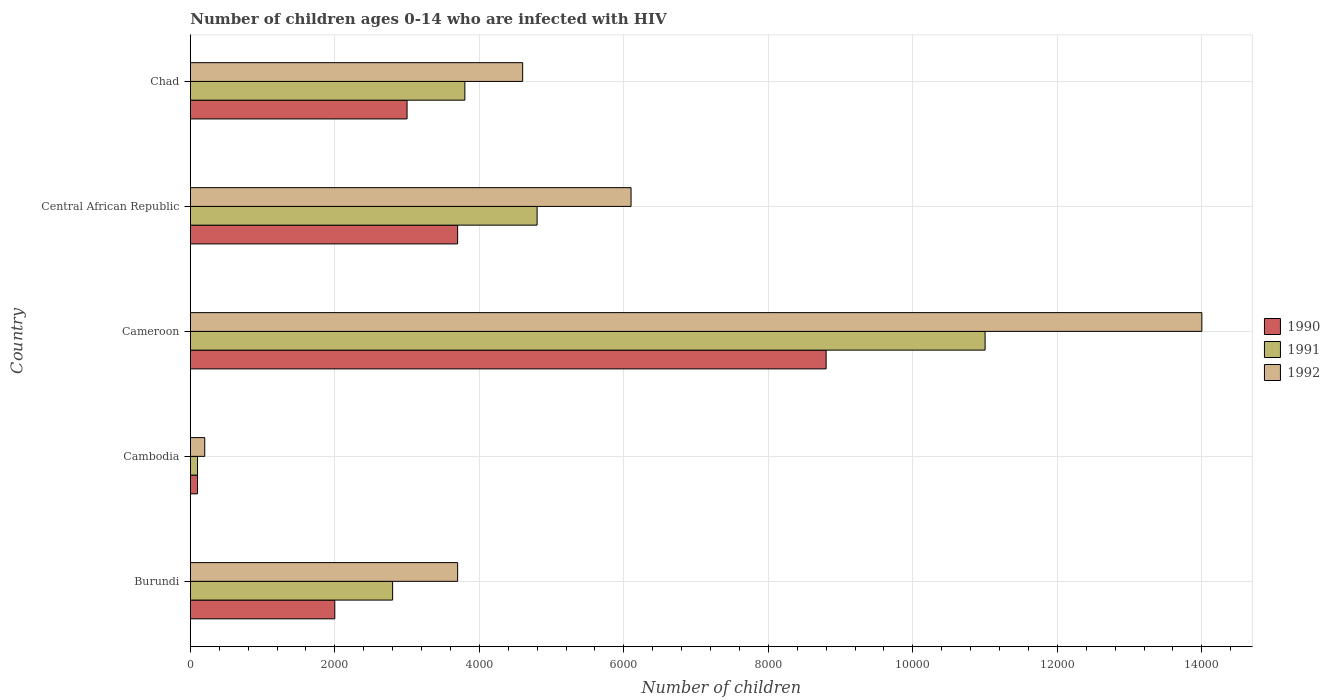How many groups of bars are there?
Ensure brevity in your answer.  5. Are the number of bars per tick equal to the number of legend labels?
Your answer should be compact. Yes. How many bars are there on the 1st tick from the top?
Ensure brevity in your answer.  3. How many bars are there on the 1st tick from the bottom?
Your answer should be very brief. 3. What is the label of the 4th group of bars from the top?
Ensure brevity in your answer.  Cambodia. What is the number of HIV infected children in 1991 in Chad?
Provide a short and direct response. 3800. Across all countries, what is the maximum number of HIV infected children in 1991?
Your answer should be very brief. 1.10e+04. Across all countries, what is the minimum number of HIV infected children in 1991?
Your answer should be compact. 100. In which country was the number of HIV infected children in 1991 maximum?
Offer a terse response. Cameroon. In which country was the number of HIV infected children in 1991 minimum?
Your response must be concise. Cambodia. What is the total number of HIV infected children in 1992 in the graph?
Provide a short and direct response. 2.86e+04. What is the difference between the number of HIV infected children in 1992 in Burundi and that in Chad?
Ensure brevity in your answer.  -900. What is the difference between the number of HIV infected children in 1991 in Cameroon and the number of HIV infected children in 1992 in Cambodia?
Ensure brevity in your answer.  1.08e+04. What is the average number of HIV infected children in 1992 per country?
Give a very brief answer. 5720. What is the difference between the number of HIV infected children in 1990 and number of HIV infected children in 1991 in Central African Republic?
Offer a terse response. -1100. What is the ratio of the number of HIV infected children in 1992 in Cameroon to that in Chad?
Make the answer very short. 3.04. Is the number of HIV infected children in 1990 in Cameroon less than that in Central African Republic?
Offer a terse response. No. Is the difference between the number of HIV infected children in 1990 in Burundi and Cambodia greater than the difference between the number of HIV infected children in 1991 in Burundi and Cambodia?
Your answer should be very brief. No. What is the difference between the highest and the second highest number of HIV infected children in 1990?
Provide a succinct answer. 5100. What is the difference between the highest and the lowest number of HIV infected children in 1992?
Make the answer very short. 1.38e+04. What does the 1st bar from the top in Chad represents?
Your answer should be compact. 1992. What does the 2nd bar from the bottom in Cameroon represents?
Your answer should be very brief. 1991. Is it the case that in every country, the sum of the number of HIV infected children in 1992 and number of HIV infected children in 1991 is greater than the number of HIV infected children in 1990?
Offer a very short reply. Yes. How many bars are there?
Keep it short and to the point. 15. Are all the bars in the graph horizontal?
Your response must be concise. Yes. Are the values on the major ticks of X-axis written in scientific E-notation?
Offer a terse response. No. Does the graph contain grids?
Offer a terse response. Yes. How many legend labels are there?
Your answer should be compact. 3. How are the legend labels stacked?
Your response must be concise. Vertical. What is the title of the graph?
Provide a short and direct response. Number of children ages 0-14 who are infected with HIV. What is the label or title of the X-axis?
Your answer should be compact. Number of children. What is the Number of children in 1990 in Burundi?
Ensure brevity in your answer.  2000. What is the Number of children of 1991 in Burundi?
Provide a short and direct response. 2800. What is the Number of children in 1992 in Burundi?
Your response must be concise. 3700. What is the Number of children in 1991 in Cambodia?
Your answer should be compact. 100. What is the Number of children of 1992 in Cambodia?
Your answer should be compact. 200. What is the Number of children in 1990 in Cameroon?
Make the answer very short. 8800. What is the Number of children of 1991 in Cameroon?
Keep it short and to the point. 1.10e+04. What is the Number of children of 1992 in Cameroon?
Give a very brief answer. 1.40e+04. What is the Number of children in 1990 in Central African Republic?
Provide a short and direct response. 3700. What is the Number of children of 1991 in Central African Republic?
Ensure brevity in your answer.  4800. What is the Number of children in 1992 in Central African Republic?
Offer a very short reply. 6100. What is the Number of children in 1990 in Chad?
Make the answer very short. 3000. What is the Number of children in 1991 in Chad?
Provide a succinct answer. 3800. What is the Number of children of 1992 in Chad?
Your answer should be compact. 4600. Across all countries, what is the maximum Number of children in 1990?
Provide a short and direct response. 8800. Across all countries, what is the maximum Number of children in 1991?
Ensure brevity in your answer.  1.10e+04. Across all countries, what is the maximum Number of children in 1992?
Offer a very short reply. 1.40e+04. Across all countries, what is the minimum Number of children of 1991?
Make the answer very short. 100. What is the total Number of children in 1990 in the graph?
Your response must be concise. 1.76e+04. What is the total Number of children of 1991 in the graph?
Offer a terse response. 2.25e+04. What is the total Number of children in 1992 in the graph?
Provide a succinct answer. 2.86e+04. What is the difference between the Number of children of 1990 in Burundi and that in Cambodia?
Your answer should be compact. 1900. What is the difference between the Number of children of 1991 in Burundi and that in Cambodia?
Your answer should be compact. 2700. What is the difference between the Number of children in 1992 in Burundi and that in Cambodia?
Offer a terse response. 3500. What is the difference between the Number of children in 1990 in Burundi and that in Cameroon?
Your response must be concise. -6800. What is the difference between the Number of children in 1991 in Burundi and that in Cameroon?
Your answer should be very brief. -8200. What is the difference between the Number of children in 1992 in Burundi and that in Cameroon?
Your response must be concise. -1.03e+04. What is the difference between the Number of children of 1990 in Burundi and that in Central African Republic?
Give a very brief answer. -1700. What is the difference between the Number of children in 1991 in Burundi and that in Central African Republic?
Your answer should be very brief. -2000. What is the difference between the Number of children of 1992 in Burundi and that in Central African Republic?
Make the answer very short. -2400. What is the difference between the Number of children of 1990 in Burundi and that in Chad?
Provide a short and direct response. -1000. What is the difference between the Number of children of 1991 in Burundi and that in Chad?
Offer a terse response. -1000. What is the difference between the Number of children of 1992 in Burundi and that in Chad?
Your response must be concise. -900. What is the difference between the Number of children of 1990 in Cambodia and that in Cameroon?
Ensure brevity in your answer.  -8700. What is the difference between the Number of children in 1991 in Cambodia and that in Cameroon?
Your answer should be very brief. -1.09e+04. What is the difference between the Number of children of 1992 in Cambodia and that in Cameroon?
Make the answer very short. -1.38e+04. What is the difference between the Number of children in 1990 in Cambodia and that in Central African Republic?
Give a very brief answer. -3600. What is the difference between the Number of children of 1991 in Cambodia and that in Central African Republic?
Make the answer very short. -4700. What is the difference between the Number of children of 1992 in Cambodia and that in Central African Republic?
Ensure brevity in your answer.  -5900. What is the difference between the Number of children of 1990 in Cambodia and that in Chad?
Your answer should be very brief. -2900. What is the difference between the Number of children in 1991 in Cambodia and that in Chad?
Give a very brief answer. -3700. What is the difference between the Number of children in 1992 in Cambodia and that in Chad?
Your response must be concise. -4400. What is the difference between the Number of children of 1990 in Cameroon and that in Central African Republic?
Your response must be concise. 5100. What is the difference between the Number of children of 1991 in Cameroon and that in Central African Republic?
Give a very brief answer. 6200. What is the difference between the Number of children of 1992 in Cameroon and that in Central African Republic?
Your answer should be compact. 7900. What is the difference between the Number of children of 1990 in Cameroon and that in Chad?
Keep it short and to the point. 5800. What is the difference between the Number of children of 1991 in Cameroon and that in Chad?
Your answer should be compact. 7200. What is the difference between the Number of children in 1992 in Cameroon and that in Chad?
Provide a short and direct response. 9400. What is the difference between the Number of children of 1990 in Central African Republic and that in Chad?
Provide a short and direct response. 700. What is the difference between the Number of children of 1991 in Central African Republic and that in Chad?
Provide a succinct answer. 1000. What is the difference between the Number of children in 1992 in Central African Republic and that in Chad?
Make the answer very short. 1500. What is the difference between the Number of children of 1990 in Burundi and the Number of children of 1991 in Cambodia?
Provide a short and direct response. 1900. What is the difference between the Number of children in 1990 in Burundi and the Number of children in 1992 in Cambodia?
Provide a succinct answer. 1800. What is the difference between the Number of children of 1991 in Burundi and the Number of children of 1992 in Cambodia?
Your answer should be very brief. 2600. What is the difference between the Number of children of 1990 in Burundi and the Number of children of 1991 in Cameroon?
Provide a short and direct response. -9000. What is the difference between the Number of children of 1990 in Burundi and the Number of children of 1992 in Cameroon?
Keep it short and to the point. -1.20e+04. What is the difference between the Number of children of 1991 in Burundi and the Number of children of 1992 in Cameroon?
Offer a terse response. -1.12e+04. What is the difference between the Number of children of 1990 in Burundi and the Number of children of 1991 in Central African Republic?
Provide a short and direct response. -2800. What is the difference between the Number of children of 1990 in Burundi and the Number of children of 1992 in Central African Republic?
Offer a terse response. -4100. What is the difference between the Number of children in 1991 in Burundi and the Number of children in 1992 in Central African Republic?
Provide a succinct answer. -3300. What is the difference between the Number of children of 1990 in Burundi and the Number of children of 1991 in Chad?
Make the answer very short. -1800. What is the difference between the Number of children in 1990 in Burundi and the Number of children in 1992 in Chad?
Make the answer very short. -2600. What is the difference between the Number of children in 1991 in Burundi and the Number of children in 1992 in Chad?
Provide a short and direct response. -1800. What is the difference between the Number of children of 1990 in Cambodia and the Number of children of 1991 in Cameroon?
Your answer should be compact. -1.09e+04. What is the difference between the Number of children of 1990 in Cambodia and the Number of children of 1992 in Cameroon?
Make the answer very short. -1.39e+04. What is the difference between the Number of children of 1991 in Cambodia and the Number of children of 1992 in Cameroon?
Your response must be concise. -1.39e+04. What is the difference between the Number of children in 1990 in Cambodia and the Number of children in 1991 in Central African Republic?
Keep it short and to the point. -4700. What is the difference between the Number of children of 1990 in Cambodia and the Number of children of 1992 in Central African Republic?
Your answer should be very brief. -6000. What is the difference between the Number of children in 1991 in Cambodia and the Number of children in 1992 in Central African Republic?
Keep it short and to the point. -6000. What is the difference between the Number of children of 1990 in Cambodia and the Number of children of 1991 in Chad?
Your answer should be compact. -3700. What is the difference between the Number of children in 1990 in Cambodia and the Number of children in 1992 in Chad?
Offer a very short reply. -4500. What is the difference between the Number of children of 1991 in Cambodia and the Number of children of 1992 in Chad?
Provide a short and direct response. -4500. What is the difference between the Number of children of 1990 in Cameroon and the Number of children of 1991 in Central African Republic?
Your answer should be compact. 4000. What is the difference between the Number of children in 1990 in Cameroon and the Number of children in 1992 in Central African Republic?
Your answer should be compact. 2700. What is the difference between the Number of children of 1991 in Cameroon and the Number of children of 1992 in Central African Republic?
Offer a terse response. 4900. What is the difference between the Number of children in 1990 in Cameroon and the Number of children in 1992 in Chad?
Ensure brevity in your answer.  4200. What is the difference between the Number of children in 1991 in Cameroon and the Number of children in 1992 in Chad?
Offer a very short reply. 6400. What is the difference between the Number of children of 1990 in Central African Republic and the Number of children of 1991 in Chad?
Provide a short and direct response. -100. What is the difference between the Number of children in 1990 in Central African Republic and the Number of children in 1992 in Chad?
Offer a terse response. -900. What is the difference between the Number of children in 1991 in Central African Republic and the Number of children in 1992 in Chad?
Keep it short and to the point. 200. What is the average Number of children in 1990 per country?
Your response must be concise. 3520. What is the average Number of children in 1991 per country?
Your answer should be very brief. 4500. What is the average Number of children of 1992 per country?
Make the answer very short. 5720. What is the difference between the Number of children in 1990 and Number of children in 1991 in Burundi?
Offer a terse response. -800. What is the difference between the Number of children of 1990 and Number of children of 1992 in Burundi?
Offer a terse response. -1700. What is the difference between the Number of children of 1991 and Number of children of 1992 in Burundi?
Your answer should be very brief. -900. What is the difference between the Number of children of 1990 and Number of children of 1991 in Cambodia?
Your answer should be compact. 0. What is the difference between the Number of children of 1990 and Number of children of 1992 in Cambodia?
Your answer should be very brief. -100. What is the difference between the Number of children in 1991 and Number of children in 1992 in Cambodia?
Ensure brevity in your answer.  -100. What is the difference between the Number of children in 1990 and Number of children in 1991 in Cameroon?
Offer a very short reply. -2200. What is the difference between the Number of children in 1990 and Number of children in 1992 in Cameroon?
Provide a succinct answer. -5200. What is the difference between the Number of children in 1991 and Number of children in 1992 in Cameroon?
Your response must be concise. -3000. What is the difference between the Number of children in 1990 and Number of children in 1991 in Central African Republic?
Your answer should be very brief. -1100. What is the difference between the Number of children in 1990 and Number of children in 1992 in Central African Republic?
Offer a very short reply. -2400. What is the difference between the Number of children of 1991 and Number of children of 1992 in Central African Republic?
Keep it short and to the point. -1300. What is the difference between the Number of children of 1990 and Number of children of 1991 in Chad?
Your answer should be compact. -800. What is the difference between the Number of children of 1990 and Number of children of 1992 in Chad?
Make the answer very short. -1600. What is the difference between the Number of children in 1991 and Number of children in 1992 in Chad?
Offer a very short reply. -800. What is the ratio of the Number of children of 1990 in Burundi to that in Cambodia?
Your answer should be very brief. 20. What is the ratio of the Number of children of 1992 in Burundi to that in Cambodia?
Make the answer very short. 18.5. What is the ratio of the Number of children in 1990 in Burundi to that in Cameroon?
Give a very brief answer. 0.23. What is the ratio of the Number of children of 1991 in Burundi to that in Cameroon?
Provide a short and direct response. 0.25. What is the ratio of the Number of children of 1992 in Burundi to that in Cameroon?
Your answer should be compact. 0.26. What is the ratio of the Number of children in 1990 in Burundi to that in Central African Republic?
Ensure brevity in your answer.  0.54. What is the ratio of the Number of children of 1991 in Burundi to that in Central African Republic?
Provide a succinct answer. 0.58. What is the ratio of the Number of children in 1992 in Burundi to that in Central African Republic?
Make the answer very short. 0.61. What is the ratio of the Number of children in 1991 in Burundi to that in Chad?
Offer a very short reply. 0.74. What is the ratio of the Number of children of 1992 in Burundi to that in Chad?
Keep it short and to the point. 0.8. What is the ratio of the Number of children of 1990 in Cambodia to that in Cameroon?
Keep it short and to the point. 0.01. What is the ratio of the Number of children of 1991 in Cambodia to that in Cameroon?
Your response must be concise. 0.01. What is the ratio of the Number of children of 1992 in Cambodia to that in Cameroon?
Keep it short and to the point. 0.01. What is the ratio of the Number of children in 1990 in Cambodia to that in Central African Republic?
Make the answer very short. 0.03. What is the ratio of the Number of children of 1991 in Cambodia to that in Central African Republic?
Keep it short and to the point. 0.02. What is the ratio of the Number of children of 1992 in Cambodia to that in Central African Republic?
Provide a short and direct response. 0.03. What is the ratio of the Number of children of 1990 in Cambodia to that in Chad?
Make the answer very short. 0.03. What is the ratio of the Number of children of 1991 in Cambodia to that in Chad?
Your answer should be compact. 0.03. What is the ratio of the Number of children in 1992 in Cambodia to that in Chad?
Offer a terse response. 0.04. What is the ratio of the Number of children in 1990 in Cameroon to that in Central African Republic?
Offer a very short reply. 2.38. What is the ratio of the Number of children in 1991 in Cameroon to that in Central African Republic?
Ensure brevity in your answer.  2.29. What is the ratio of the Number of children in 1992 in Cameroon to that in Central African Republic?
Your response must be concise. 2.3. What is the ratio of the Number of children of 1990 in Cameroon to that in Chad?
Your response must be concise. 2.93. What is the ratio of the Number of children of 1991 in Cameroon to that in Chad?
Provide a succinct answer. 2.89. What is the ratio of the Number of children in 1992 in Cameroon to that in Chad?
Provide a succinct answer. 3.04. What is the ratio of the Number of children of 1990 in Central African Republic to that in Chad?
Your response must be concise. 1.23. What is the ratio of the Number of children of 1991 in Central African Republic to that in Chad?
Give a very brief answer. 1.26. What is the ratio of the Number of children of 1992 in Central African Republic to that in Chad?
Offer a terse response. 1.33. What is the difference between the highest and the second highest Number of children in 1990?
Provide a short and direct response. 5100. What is the difference between the highest and the second highest Number of children of 1991?
Offer a very short reply. 6200. What is the difference between the highest and the second highest Number of children of 1992?
Provide a succinct answer. 7900. What is the difference between the highest and the lowest Number of children in 1990?
Your response must be concise. 8700. What is the difference between the highest and the lowest Number of children of 1991?
Make the answer very short. 1.09e+04. What is the difference between the highest and the lowest Number of children of 1992?
Ensure brevity in your answer.  1.38e+04. 